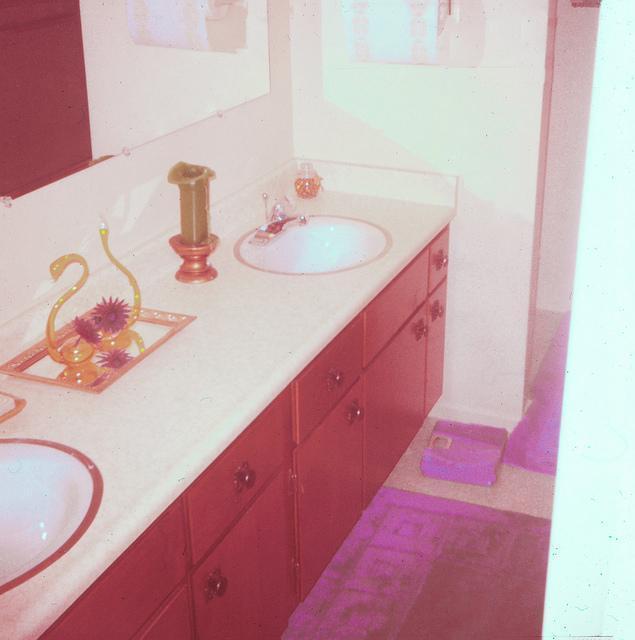How many sinks can you see?
Give a very brief answer. 2. How many zebras are there?
Give a very brief answer. 0. 